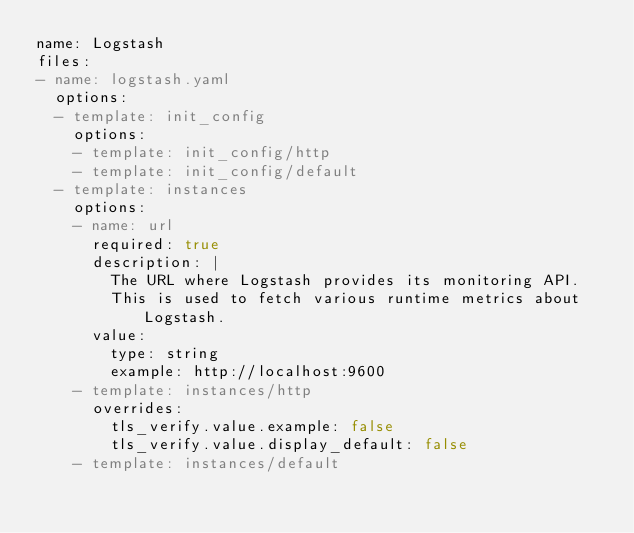Convert code to text. <code><loc_0><loc_0><loc_500><loc_500><_YAML_>name: Logstash
files:
- name: logstash.yaml
  options:
  - template: init_config
    options:
    - template: init_config/http
    - template: init_config/default
  - template: instances
    options:
    - name: url
      required: true
      description: |
        The URL where Logstash provides its monitoring API.
        This is used to fetch various runtime metrics about Logstash.
      value:
        type: string
        example: http://localhost:9600
    - template: instances/http
      overrides: 
        tls_verify.value.example: false
        tls_verify.value.display_default: false
    - template: instances/default
</code> 